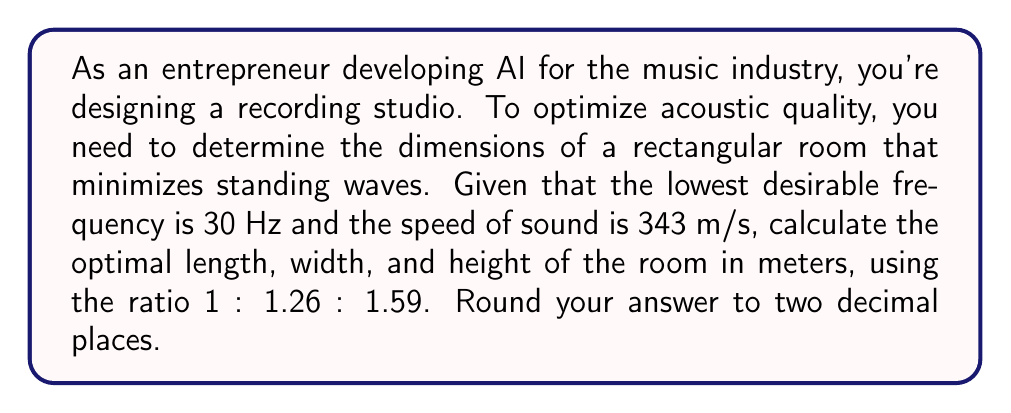What is the answer to this math problem? 1. The wave equation for a rectangular room is given by:

   $$f_{nml} = \frac{c}{2} \sqrt{\left(\frac{n}{L_x}\right)^2 + \left(\frac{m}{L_y}\right)^2 + \left(\frac{l}{L_z}\right)^2}$$

   where $f_{nml}$ is the resonant frequency, $c$ is the speed of sound, and $L_x$, $L_y$, and $L_z$ are the room dimensions.

2. For the lowest frequency mode (1,0,0), we have:

   $$f_{100} = \frac{c}{2L_x}$$

3. Rearranging for $L_x$:

   $$L_x = \frac{c}{2f_{100}} = \frac{343}{2 \cdot 30} = 5.72\text{ m}$$

4. Using the given ratio 1 : 1.26 : 1.59, we can calculate $L_y$ and $L_z$:

   $$L_y = 1.26 \cdot 5.72 = 7.21\text{ m}$$
   $$L_z = 1.59 \cdot 5.72 = 9.09\text{ m}$$

5. Rounding to two decimal places:
   $L_x = 5.72\text{ m}$
   $L_y = 7.21\text{ m}$
   $L_z = 9.09\text{ m}$
Answer: 5.72 m, 7.21 m, 9.09 m 